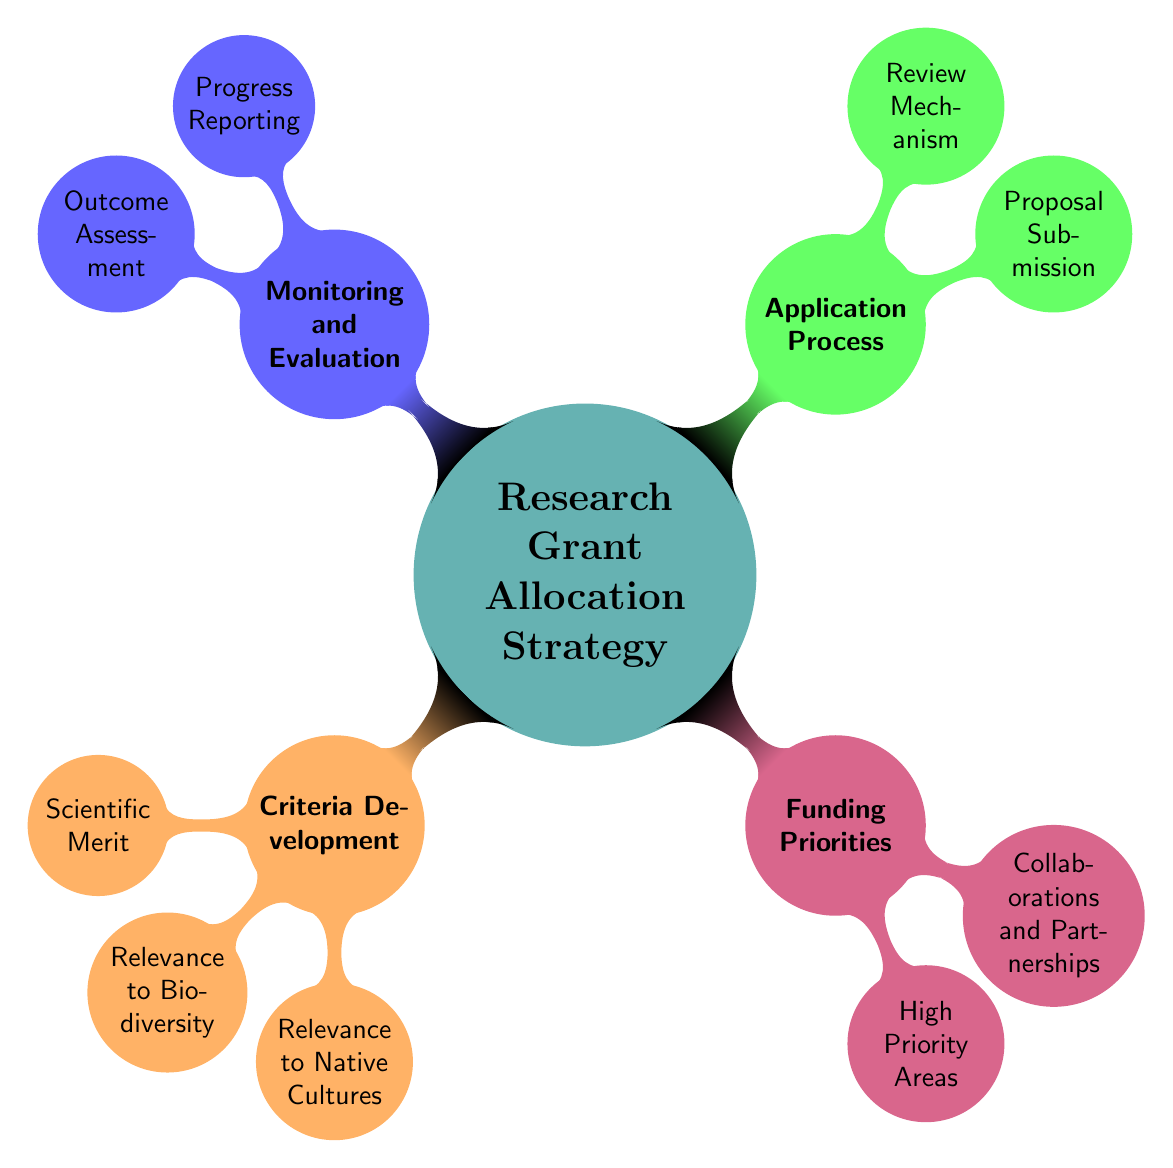What are the three main branches of the diagram? The diagram has four main branches: Criteria Development, Funding Priorities, Application Process, and Monitoring and Evaluation. Each branch contains sub-nodes detailing various aspects of the research grant allocation strategy.
Answer: Criteria Development, Funding Priorities, Application Process, Monitoring and Evaluation How many nodes are under Criteria Development? Under the branch of Criteria Development, there are three nodes: Scientific Merit, Relevance to Biodiversity, and Relevance to Native Cultures. This is determined by counting the immediate children of the Criteria Development node.
Answer: 3 What is a key focus in the Funding Priorities area? The Funding Priorities area highlights two main focuses: High Priority Areas and Collaborations and Partnerships. These are identified as the direct sub-nodes of the Funding Priorities branch.
Answer: High Priority Areas, Collaborations and Partnerships Which aspect of Relevance to Native Cultures includes "Cultural Heritage Preservation"? "Cultural Heritage Preservation" is part of the Relevance to Native Cultures node. It indicates a focus on preserving cultural aspects in research. This is found by looking at the sub-nodes of the Relevance to Native Cultures node.
Answer: Relevance to Native Cultures What is one method for Proposal Submission indicated in the diagram? The Proposal Submission aspect includes "Clear Guidelines" as one of its defined methods. This is determined by examining the sub-nodes of the Application Process branch, specifically under Proposal Submission.
Answer: Clear Guidelines What type of assessments are done in Monitoring and Evaluation? In Monitoring and Evaluation, there are two main types of assessments: Progress Reporting and Outcome Assessment. These categories highlight how the research projects are monitored and evaluated. This information is acquired by looking at the sub-nodes of the Monitoring and Evaluation section.
Answer: Progress Reporting, Outcome Assessment Which node relates to "Traditional Knowledge Systems"? "Traditional Knowledge Systems" is a key focus under the High Priority Areas in the Funding Priorities branch. To arrive at this answer, we identify the node structure leading from Funding Priorities to High Priority Areas and then locate Traditional Knowledge Systems as a sub-node.
Answer: High Priority Areas What do the Review Mechanism sub-nodes measure? The Review Mechanism sub-nodes measure the evaluation aspects of grant applications, specifically including Peer Review, Expert Panels, and Conflict of Interest Management. This is discerned by examining the Application Process branch, particularly under the Review Mechanism node.
Answer: Evaluation aspects What two main components are included in Outcome Assessment? The Outcome Assessment includes "Publication of Results" and "Impact on Policy." This is derived from analyzing the sub-nodes directly under Outcome Assessment within the Monitoring and Evaluation branch.
Answer: Publication of Results, Impact on Policy 